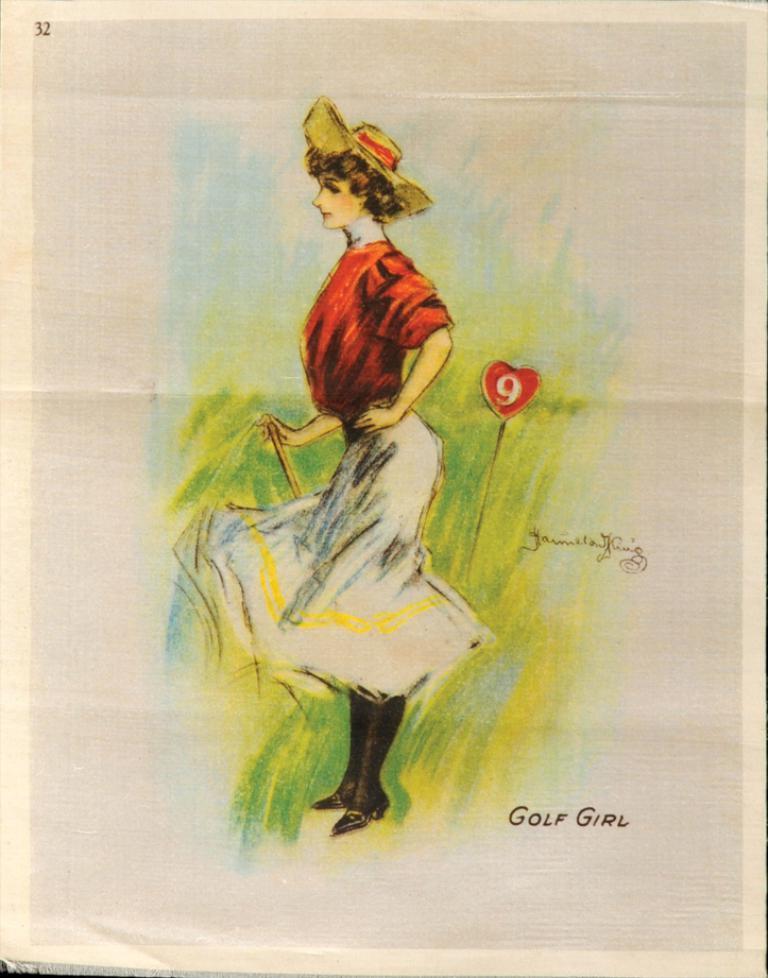In one or two sentences, can you explain what this image depicts? In this image I can see the painting of a person on the paper. I can see something is written on the paper. 